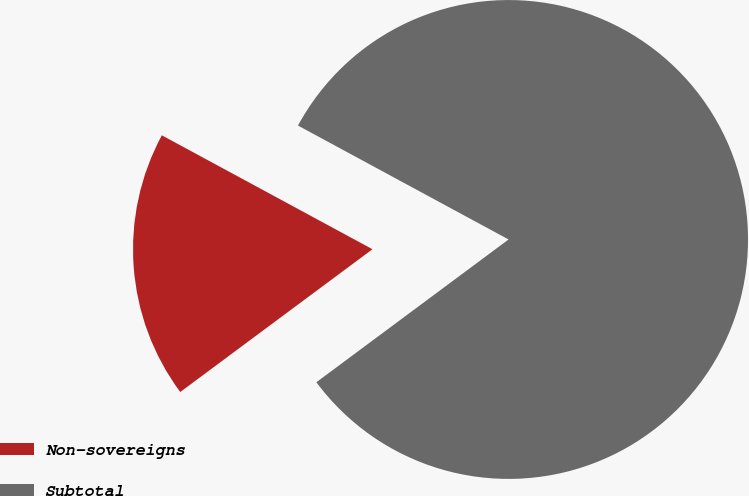<chart> <loc_0><loc_0><loc_500><loc_500><pie_chart><fcel>Non-sovereigns<fcel>Subtotal<nl><fcel>18.06%<fcel>81.94%<nl></chart> 